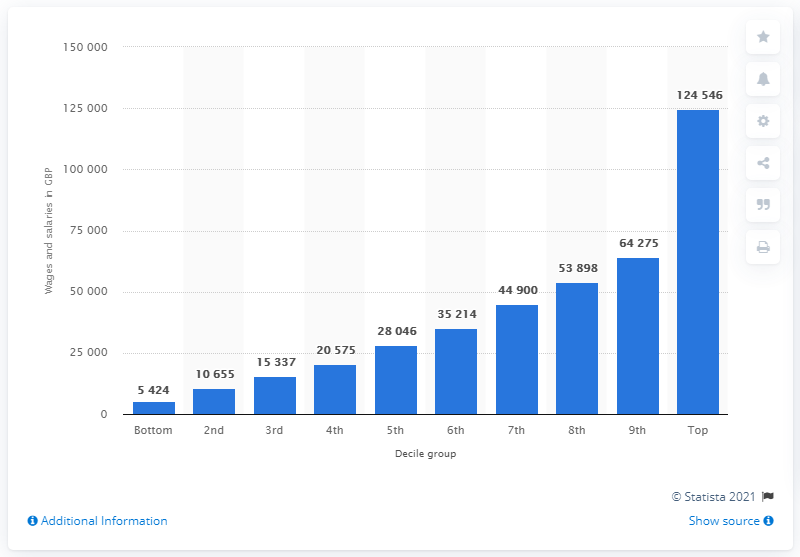Give some essential details in this illustration. According to the data, the average annual wages and salaries per household for those in the bottom decile was approximately 5,424 USD. The average annual wages and salaries per household for those in the top decile was 124,546. 